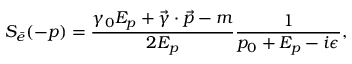<formula> <loc_0><loc_0><loc_500><loc_500>S _ { \bar { e } } ( - p ) = \frac { \gamma _ { 0 } E _ { p } + \vec { \gamma } \cdot \vec { p } - m } { 2 E _ { p } } \frac { 1 } { p _ { 0 } + E _ { p } - i \epsilon } ,</formula> 